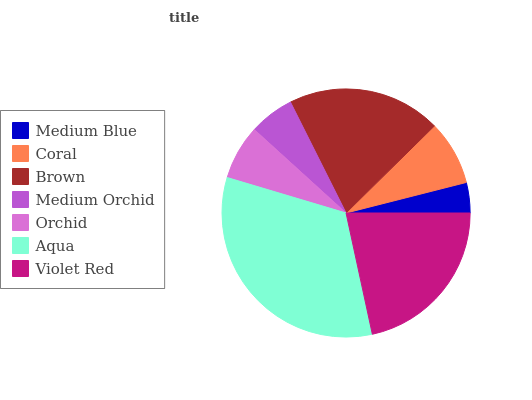Is Medium Blue the minimum?
Answer yes or no. Yes. Is Aqua the maximum?
Answer yes or no. Yes. Is Coral the minimum?
Answer yes or no. No. Is Coral the maximum?
Answer yes or no. No. Is Coral greater than Medium Blue?
Answer yes or no. Yes. Is Medium Blue less than Coral?
Answer yes or no. Yes. Is Medium Blue greater than Coral?
Answer yes or no. No. Is Coral less than Medium Blue?
Answer yes or no. No. Is Coral the high median?
Answer yes or no. Yes. Is Coral the low median?
Answer yes or no. Yes. Is Aqua the high median?
Answer yes or no. No. Is Violet Red the low median?
Answer yes or no. No. 